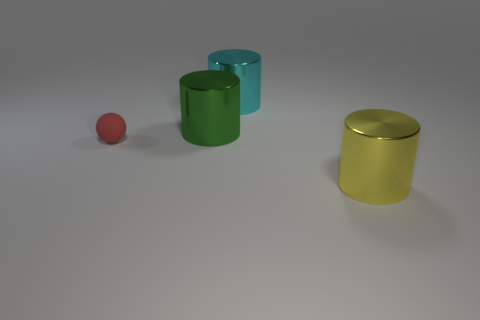Subtract all cyan cylinders. How many cylinders are left? 2 Add 3 big spheres. How many objects exist? 7 Subtract all cylinders. How many objects are left? 1 Subtract 0 brown cylinders. How many objects are left? 4 Subtract all cyan balls. Subtract all brown cylinders. How many balls are left? 1 Subtract all big blue shiny cubes. Subtract all large green objects. How many objects are left? 3 Add 3 big cyan cylinders. How many big cyan cylinders are left? 4 Add 1 large cyan cylinders. How many large cyan cylinders exist? 2 